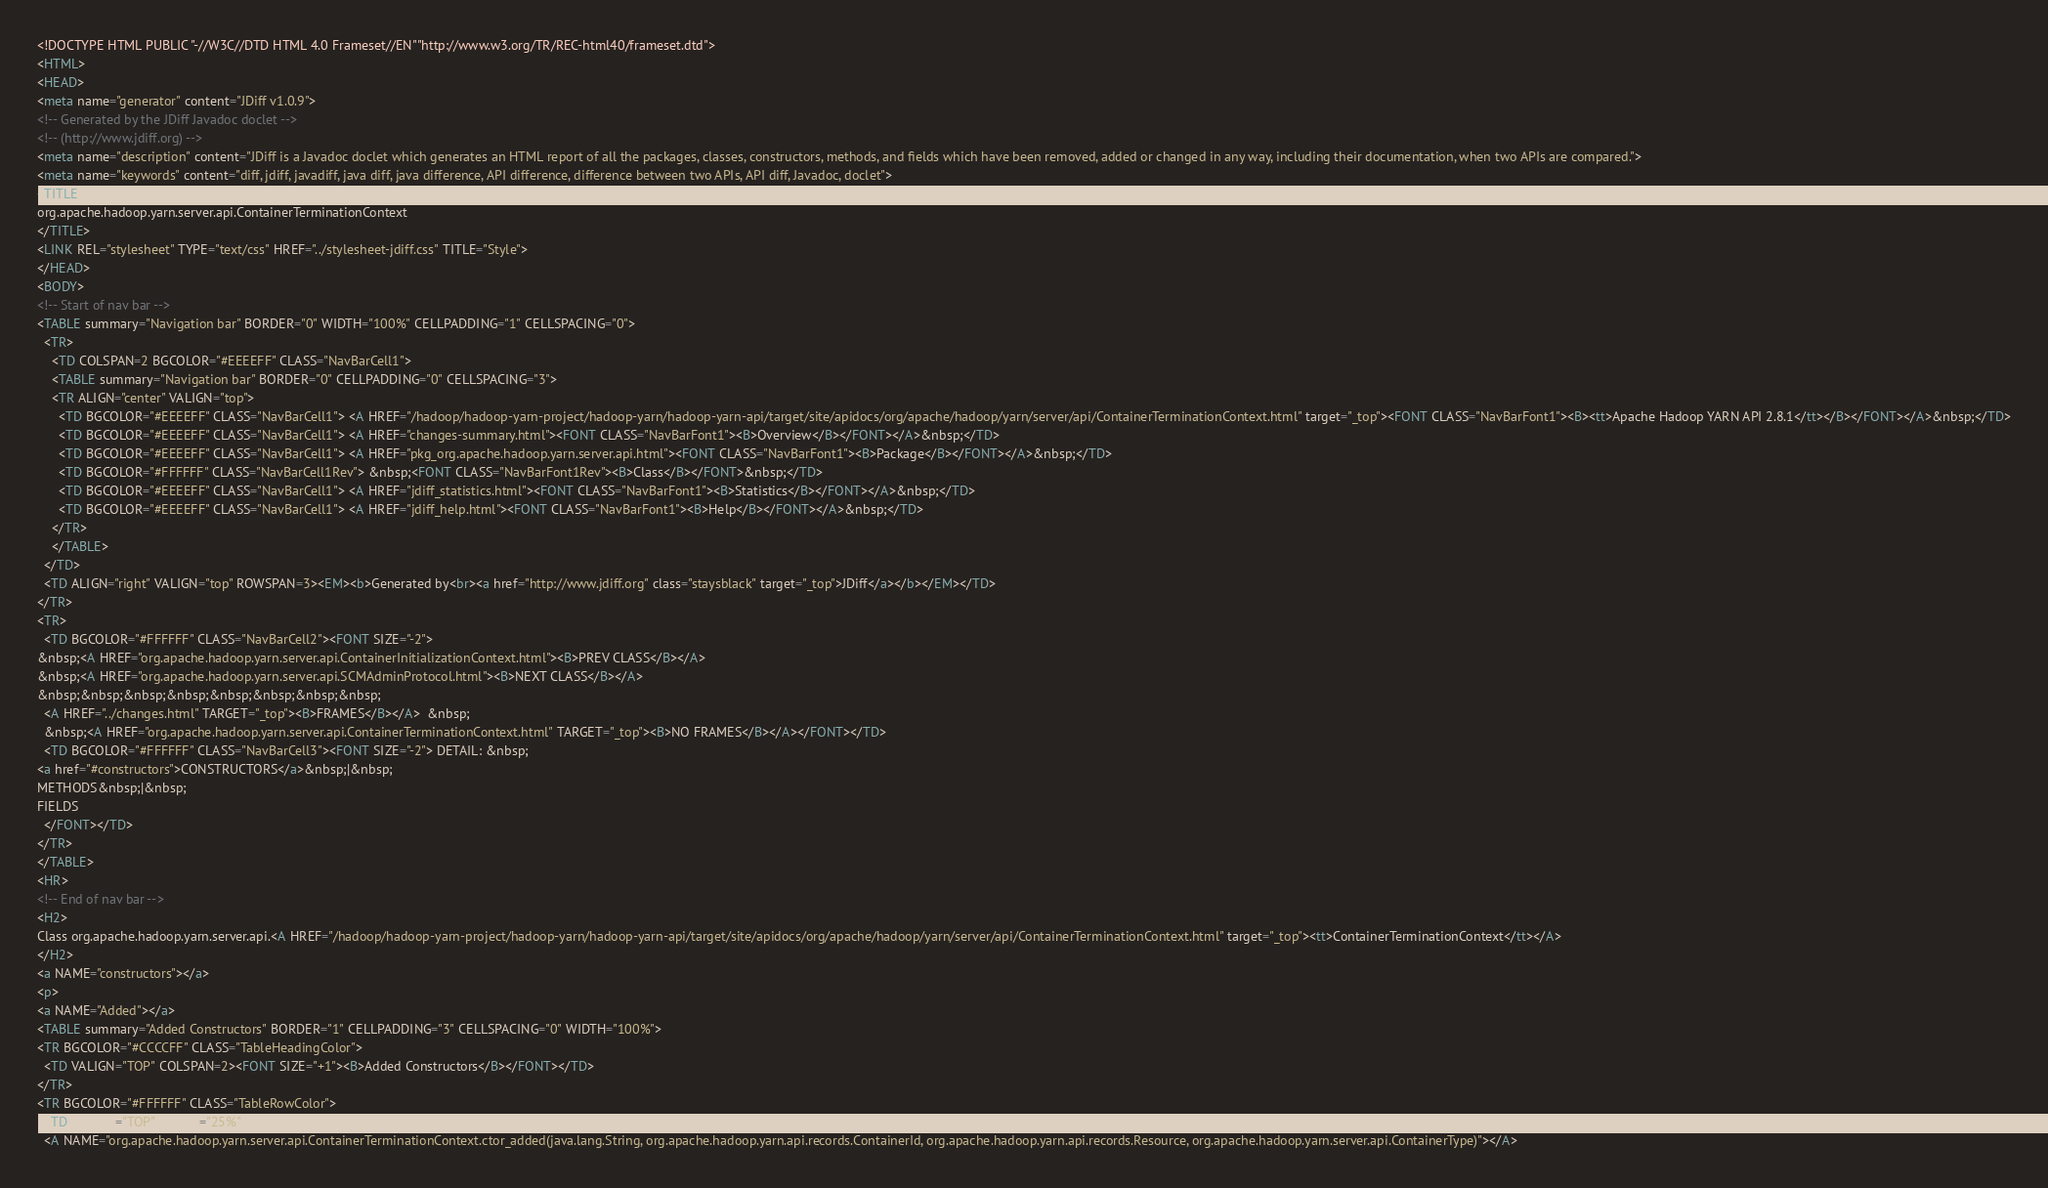Convert code to text. <code><loc_0><loc_0><loc_500><loc_500><_HTML_><!DOCTYPE HTML PUBLIC "-//W3C//DTD HTML 4.0 Frameset//EN""http://www.w3.org/TR/REC-html40/frameset.dtd">
<HTML>
<HEAD>
<meta name="generator" content="JDiff v1.0.9">
<!-- Generated by the JDiff Javadoc doclet -->
<!-- (http://www.jdiff.org) -->
<meta name="description" content="JDiff is a Javadoc doclet which generates an HTML report of all the packages, classes, constructors, methods, and fields which have been removed, added or changed in any way, including their documentation, when two APIs are compared.">
<meta name="keywords" content="diff, jdiff, javadiff, java diff, java difference, API difference, difference between two APIs, API diff, Javadoc, doclet">
<TITLE>
org.apache.hadoop.yarn.server.api.ContainerTerminationContext
</TITLE>
<LINK REL="stylesheet" TYPE="text/css" HREF="../stylesheet-jdiff.css" TITLE="Style">
</HEAD>
<BODY>
<!-- Start of nav bar -->
<TABLE summary="Navigation bar" BORDER="0" WIDTH="100%" CELLPADDING="1" CELLSPACING="0">
  <TR>
    <TD COLSPAN=2 BGCOLOR="#EEEEFF" CLASS="NavBarCell1">
    <TABLE summary="Navigation bar" BORDER="0" CELLPADDING="0" CELLSPACING="3">
    <TR ALIGN="center" VALIGN="top">
      <TD BGCOLOR="#EEEEFF" CLASS="NavBarCell1"> <A HREF="/hadoop/hadoop-yarn-project/hadoop-yarn/hadoop-yarn-api/target/site/apidocs/org/apache/hadoop/yarn/server/api/ContainerTerminationContext.html" target="_top"><FONT CLASS="NavBarFont1"><B><tt>Apache Hadoop YARN API 2.8.1</tt></B></FONT></A>&nbsp;</TD>
      <TD BGCOLOR="#EEEEFF" CLASS="NavBarCell1"> <A HREF="changes-summary.html"><FONT CLASS="NavBarFont1"><B>Overview</B></FONT></A>&nbsp;</TD>
      <TD BGCOLOR="#EEEEFF" CLASS="NavBarCell1"> <A HREF="pkg_org.apache.hadoop.yarn.server.api.html"><FONT CLASS="NavBarFont1"><B>Package</B></FONT></A>&nbsp;</TD>
      <TD BGCOLOR="#FFFFFF" CLASS="NavBarCell1Rev"> &nbsp;<FONT CLASS="NavBarFont1Rev"><B>Class</B></FONT>&nbsp;</TD>
      <TD BGCOLOR="#EEEEFF" CLASS="NavBarCell1"> <A HREF="jdiff_statistics.html"><FONT CLASS="NavBarFont1"><B>Statistics</B></FONT></A>&nbsp;</TD>
      <TD BGCOLOR="#EEEEFF" CLASS="NavBarCell1"> <A HREF="jdiff_help.html"><FONT CLASS="NavBarFont1"><B>Help</B></FONT></A>&nbsp;</TD>
    </TR>
    </TABLE>
  </TD>
  <TD ALIGN="right" VALIGN="top" ROWSPAN=3><EM><b>Generated by<br><a href="http://www.jdiff.org" class="staysblack" target="_top">JDiff</a></b></EM></TD>
</TR>
<TR>
  <TD BGCOLOR="#FFFFFF" CLASS="NavBarCell2"><FONT SIZE="-2">
&nbsp;<A HREF="org.apache.hadoop.yarn.server.api.ContainerInitializationContext.html"><B>PREV CLASS</B></A>
&nbsp;<A HREF="org.apache.hadoop.yarn.server.api.SCMAdminProtocol.html"><B>NEXT CLASS</B></A>
&nbsp;&nbsp;&nbsp;&nbsp;&nbsp;&nbsp;&nbsp;&nbsp;
  <A HREF="../changes.html" TARGET="_top"><B>FRAMES</B></A>  &nbsp;
  &nbsp;<A HREF="org.apache.hadoop.yarn.server.api.ContainerTerminationContext.html" TARGET="_top"><B>NO FRAMES</B></A></FONT></TD>
  <TD BGCOLOR="#FFFFFF" CLASS="NavBarCell3"><FONT SIZE="-2"> DETAIL: &nbsp;
<a href="#constructors">CONSTRUCTORS</a>&nbsp;|&nbsp;
METHODS&nbsp;|&nbsp;
FIELDS
  </FONT></TD>
</TR>
</TABLE>
<HR>
<!-- End of nav bar -->
<H2>
Class org.apache.hadoop.yarn.server.api.<A HREF="/hadoop/hadoop-yarn-project/hadoop-yarn/hadoop-yarn-api/target/site/apidocs/org/apache/hadoop/yarn/server/api/ContainerTerminationContext.html" target="_top"><tt>ContainerTerminationContext</tt></A>
</H2>
<a NAME="constructors"></a>
<p>
<a NAME="Added"></a>
<TABLE summary="Added Constructors" BORDER="1" CELLPADDING="3" CELLSPACING="0" WIDTH="100%">
<TR BGCOLOR="#CCCCFF" CLASS="TableHeadingColor">
  <TD VALIGN="TOP" COLSPAN=2><FONT SIZE="+1"><B>Added Constructors</B></FONT></TD>
</TR>
<TR BGCOLOR="#FFFFFF" CLASS="TableRowColor">
  <TD VALIGN="TOP" WIDTH="25%">
  <A NAME="org.apache.hadoop.yarn.server.api.ContainerTerminationContext.ctor_added(java.lang.String, org.apache.hadoop.yarn.api.records.ContainerId, org.apache.hadoop.yarn.api.records.Resource, org.apache.hadoop.yarn.server.api.ContainerType)"></A></code> 